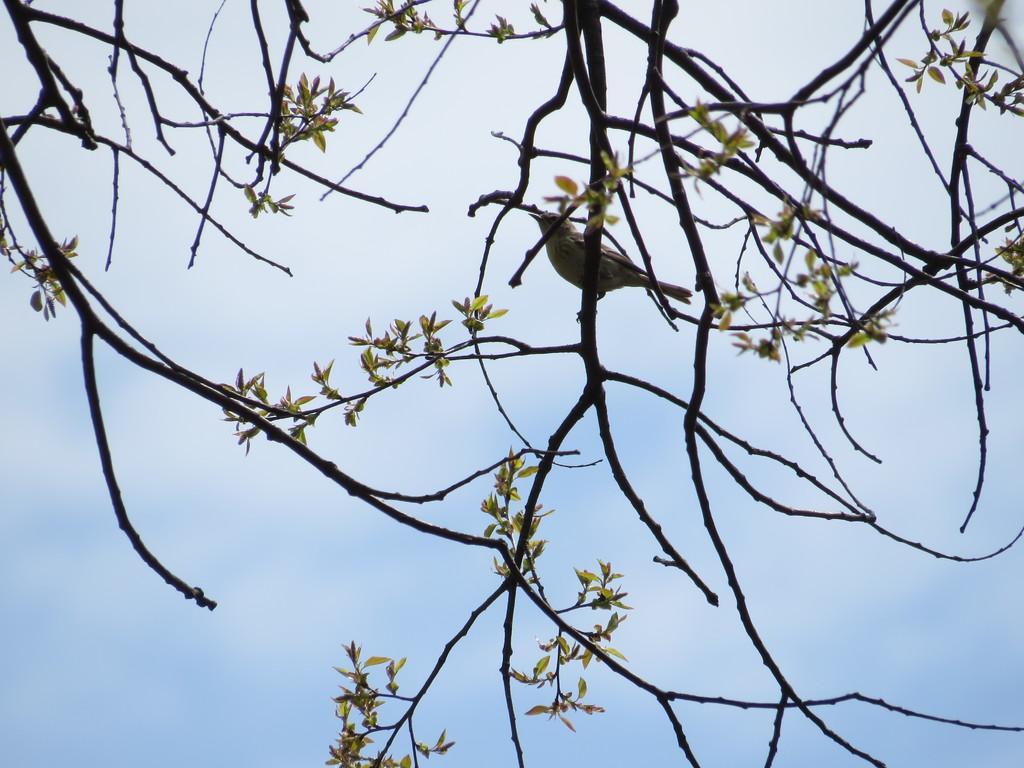Can you describe this image briefly? In this image, in the middle, we can see a bird standing on the tree stem. In the background, we can see some tree stems and leaves and a sky. 